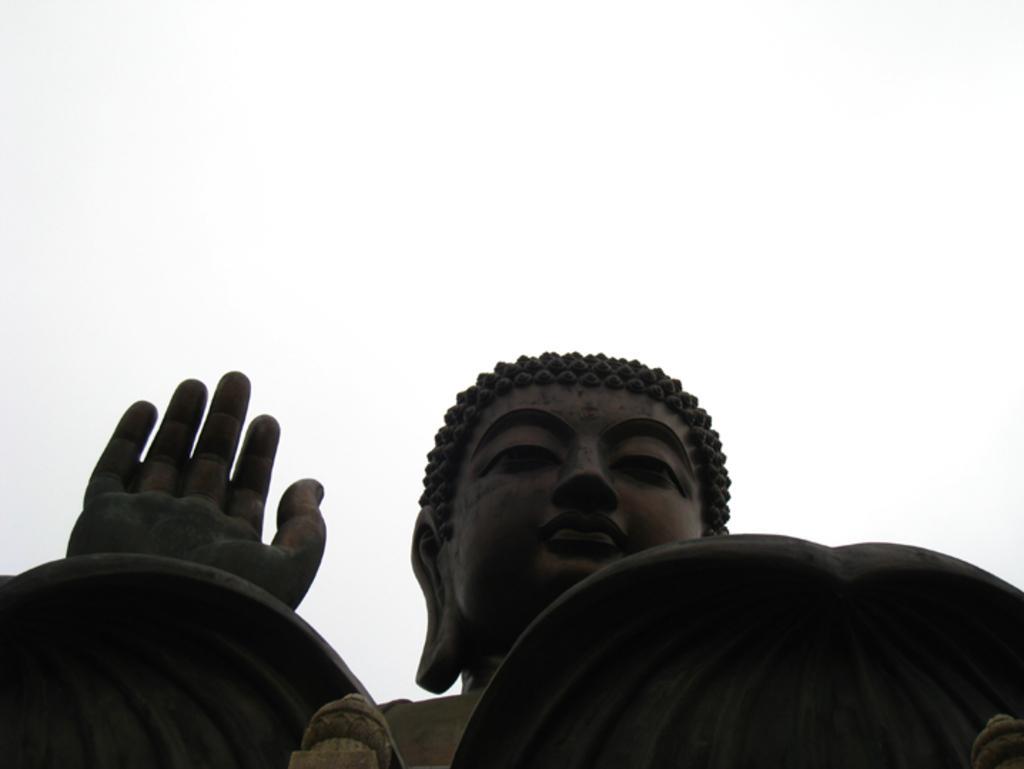Can you describe this image briefly? In this picture there is a statue of Buddha. At the top there is sky. 